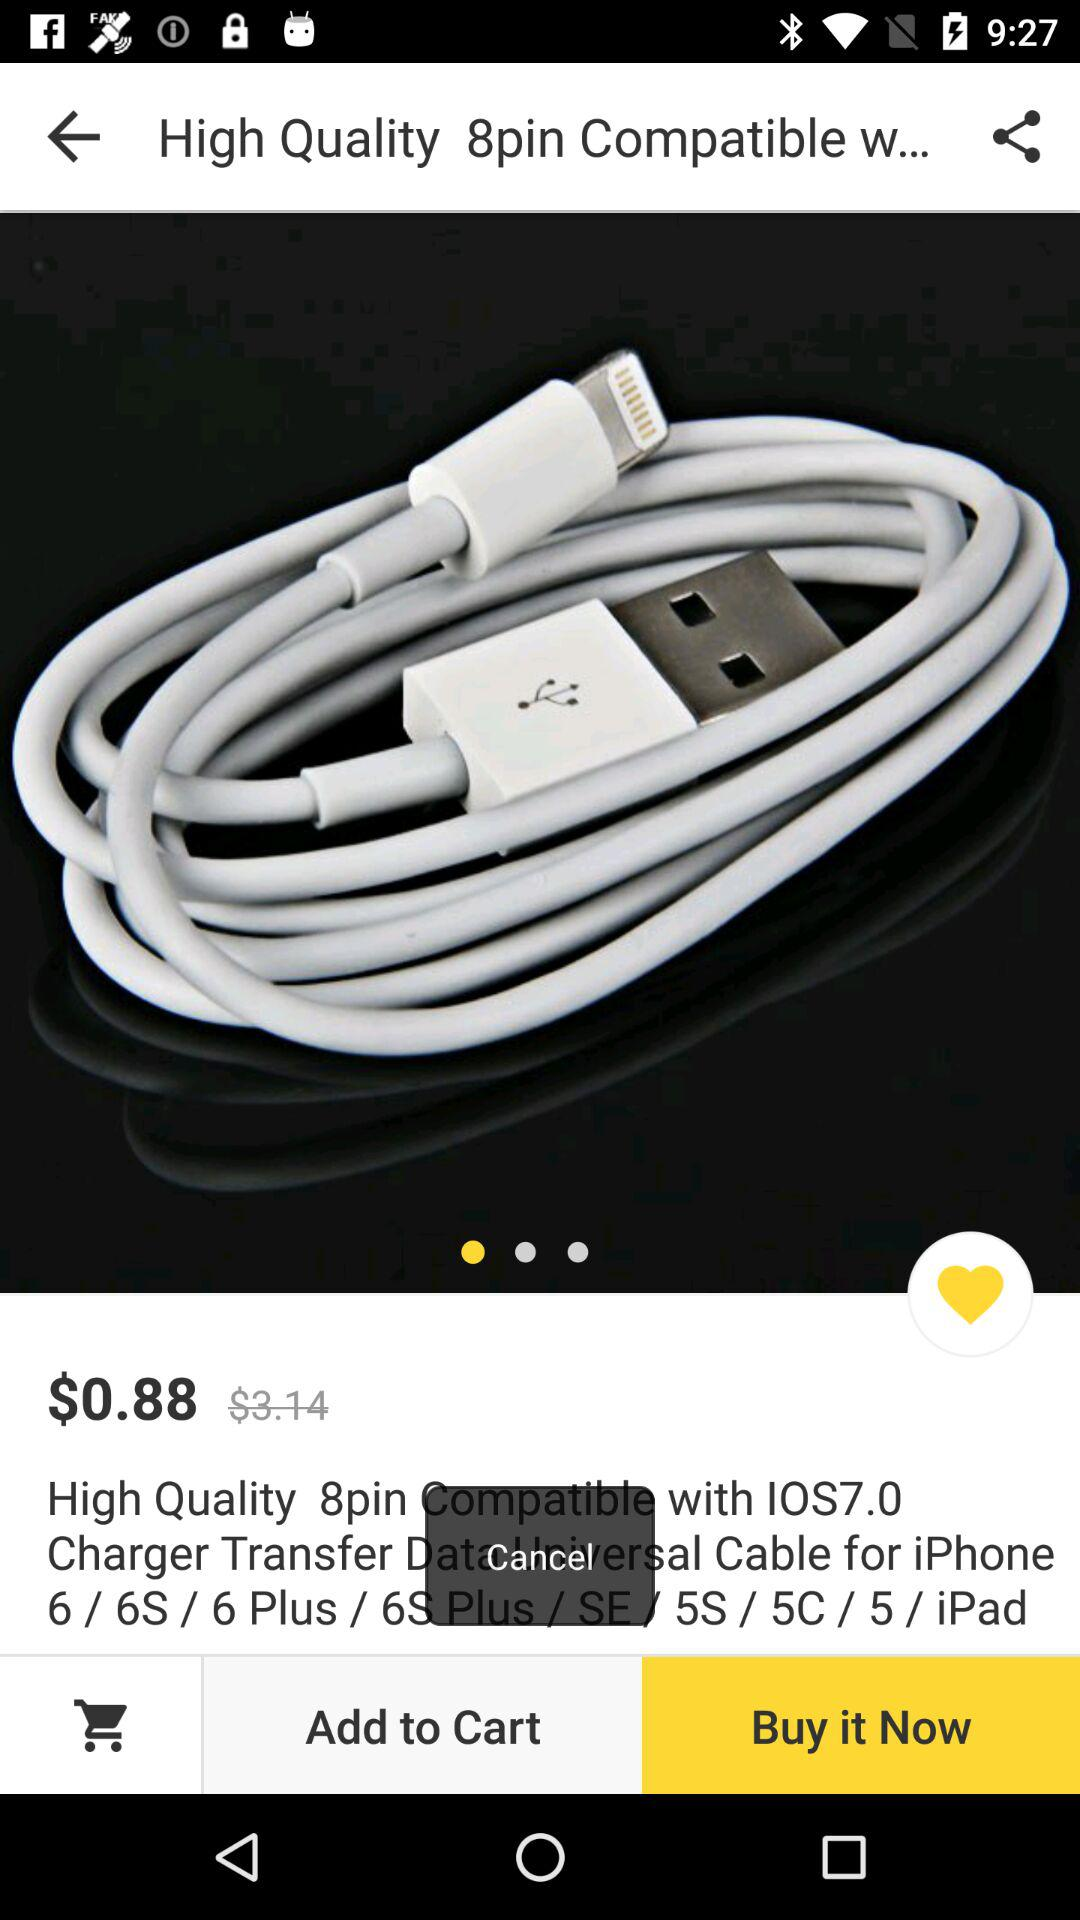What is the price of "Transfer Data Universal Cable"? The price is $0.88. 